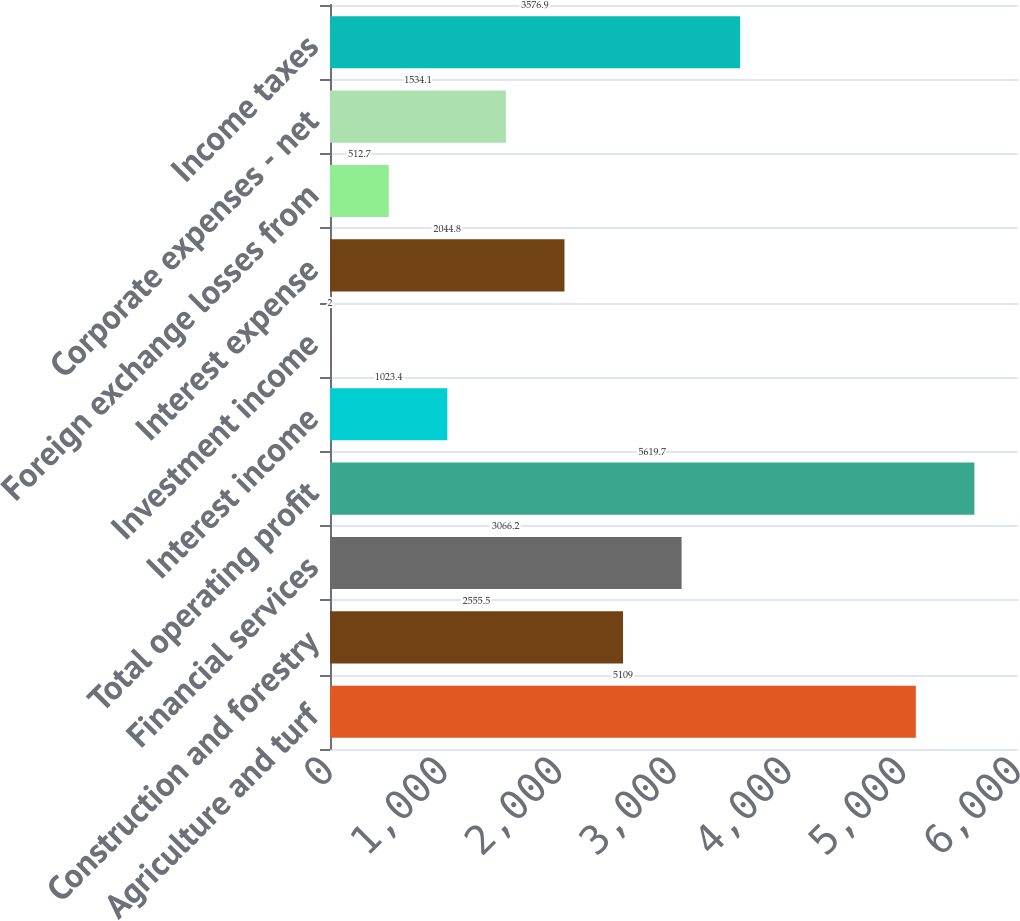<chart> <loc_0><loc_0><loc_500><loc_500><bar_chart><fcel>Agriculture and turf<fcel>Construction and forestry<fcel>Financial services<fcel>Total operating profit<fcel>Interest income<fcel>Investment income<fcel>Interest expense<fcel>Foreign exchange losses from<fcel>Corporate expenses - net<fcel>Income taxes<nl><fcel>5109<fcel>2555.5<fcel>3066.2<fcel>5619.7<fcel>1023.4<fcel>2<fcel>2044.8<fcel>512.7<fcel>1534.1<fcel>3576.9<nl></chart> 